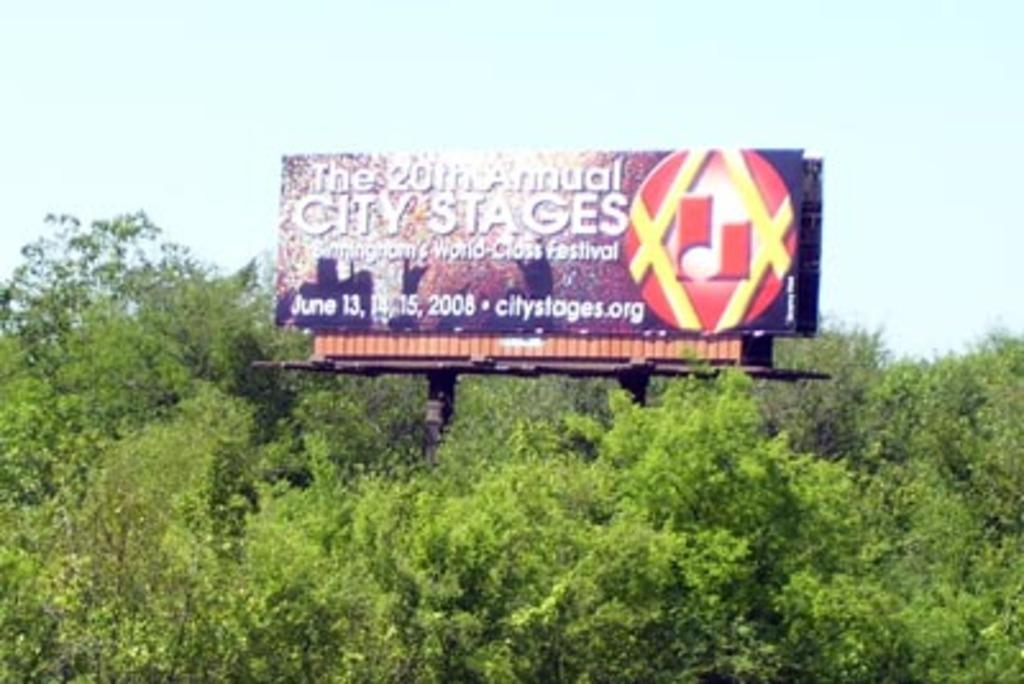<image>
Provide a brief description of the given image. A billboard for the 20th Annual City Stages in Birmingham 